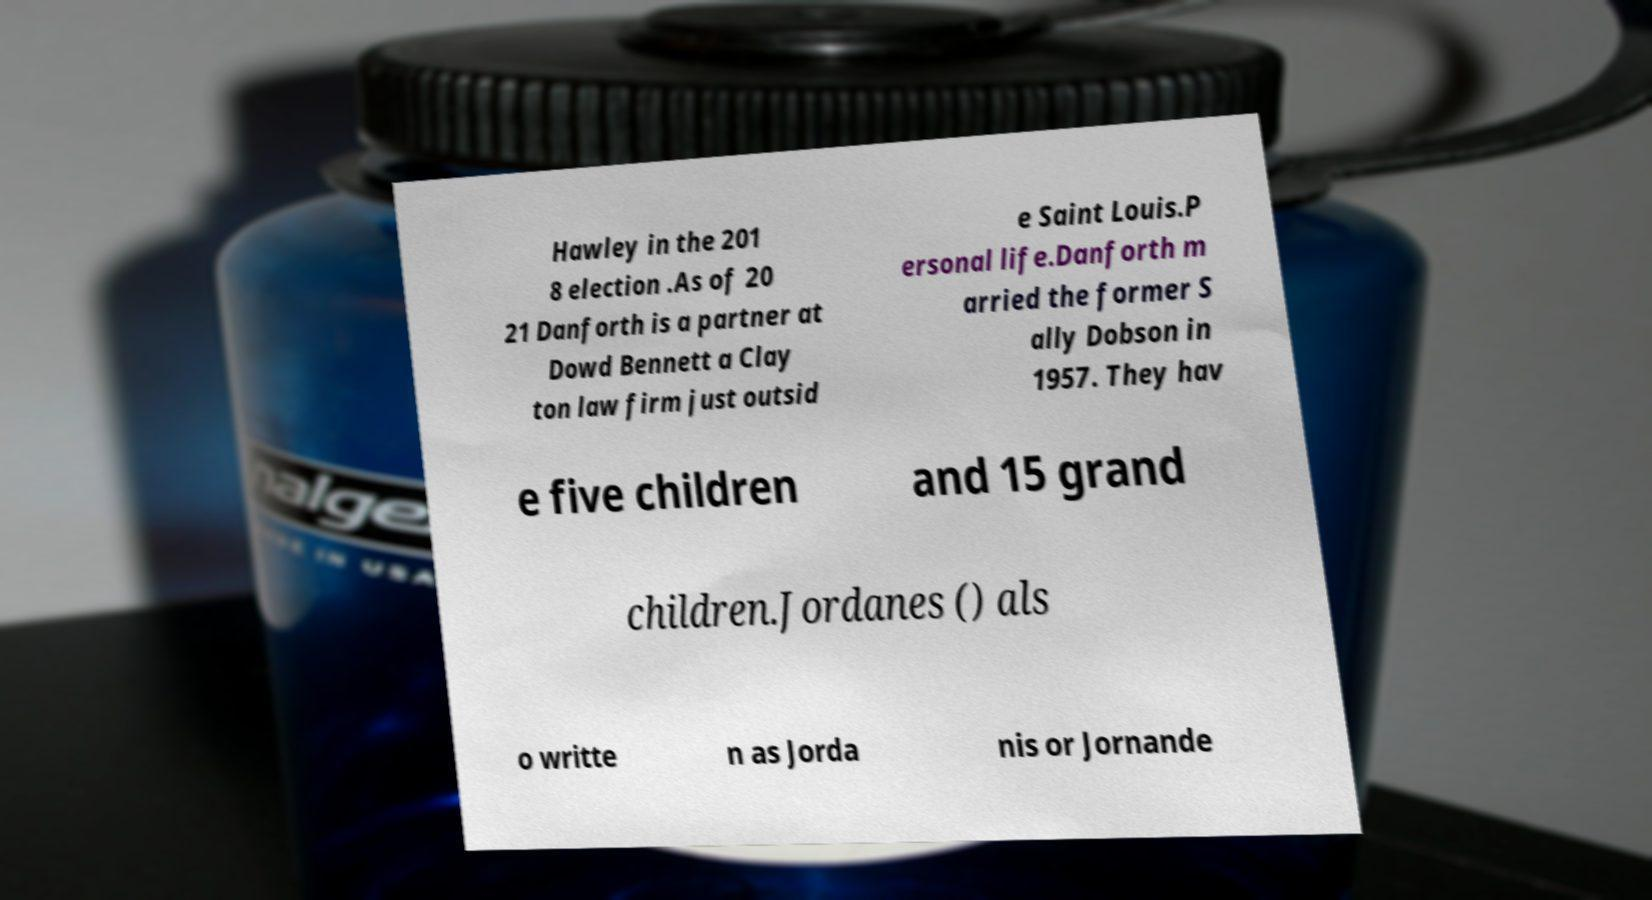I need the written content from this picture converted into text. Can you do that? Hawley in the 201 8 election .As of 20 21 Danforth is a partner at Dowd Bennett a Clay ton law firm just outsid e Saint Louis.P ersonal life.Danforth m arried the former S ally Dobson in 1957. They hav e five children and 15 grand children.Jordanes () als o writte n as Jorda nis or Jornande 